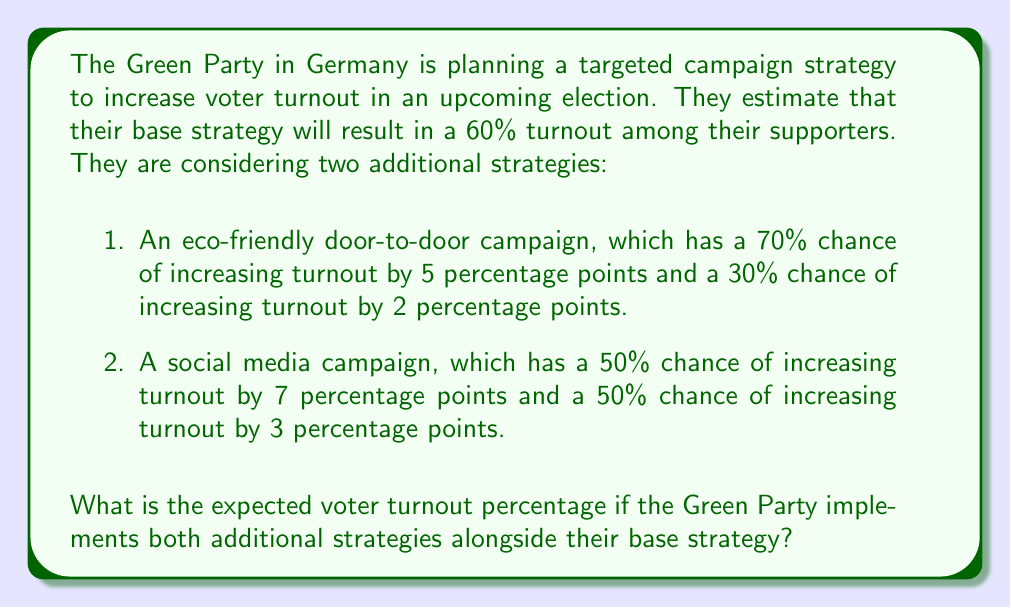Teach me how to tackle this problem. Let's approach this step-by-step:

1. Start with the base turnout:
   Base turnout = 60%

2. Calculate the expected increase from the door-to-door campaign:
   $E(\text{door-to-door}) = 0.70 \times 5 + 0.30 \times 2 = 3.5 + 0.6 = 4.1$ percentage points

3. Calculate the expected increase from the social media campaign:
   $E(\text{social media}) = 0.50 \times 7 + 0.50 \times 3 = 3.5 + 1.5 = 5$ percentage points

4. Sum up the expected increases:
   Total expected increase = 4.1 + 5 = 9.1 percentage points

5. Add the expected increase to the base turnout:
   $\text{Expected turnout} = 60\% + 9.1\% = 69.1\%$

Therefore, the expected voter turnout percentage if both additional strategies are implemented is 69.1%.
Answer: 69.1% 